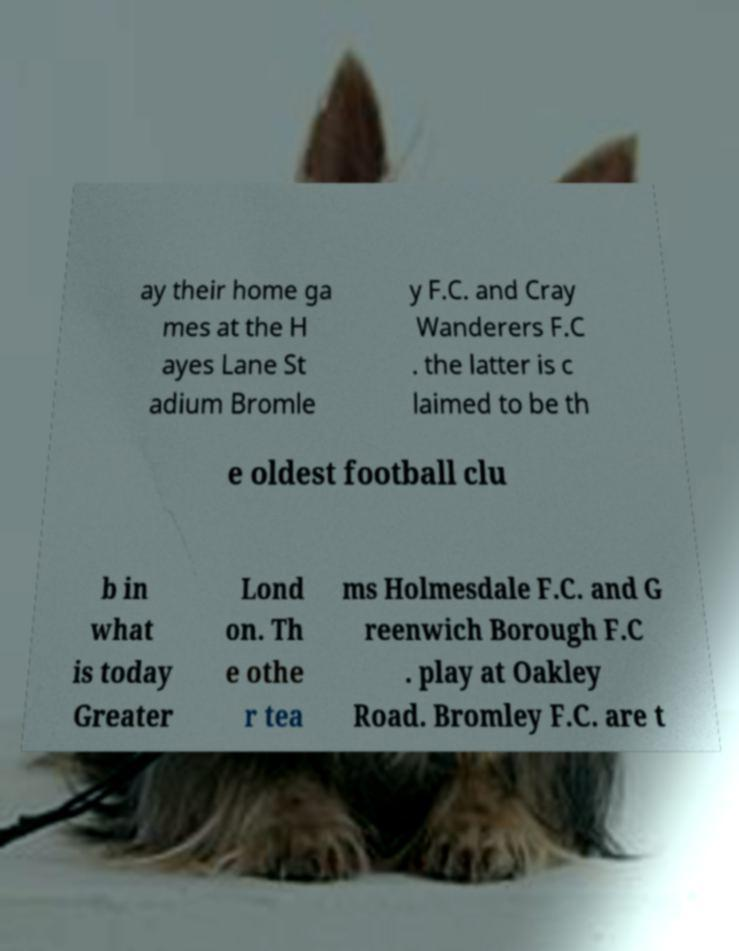There's text embedded in this image that I need extracted. Can you transcribe it verbatim? ay their home ga mes at the H ayes Lane St adium Bromle y F.C. and Cray Wanderers F.C . the latter is c laimed to be th e oldest football clu b in what is today Greater Lond on. Th e othe r tea ms Holmesdale F.C. and G reenwich Borough F.C . play at Oakley Road. Bromley F.C. are t 